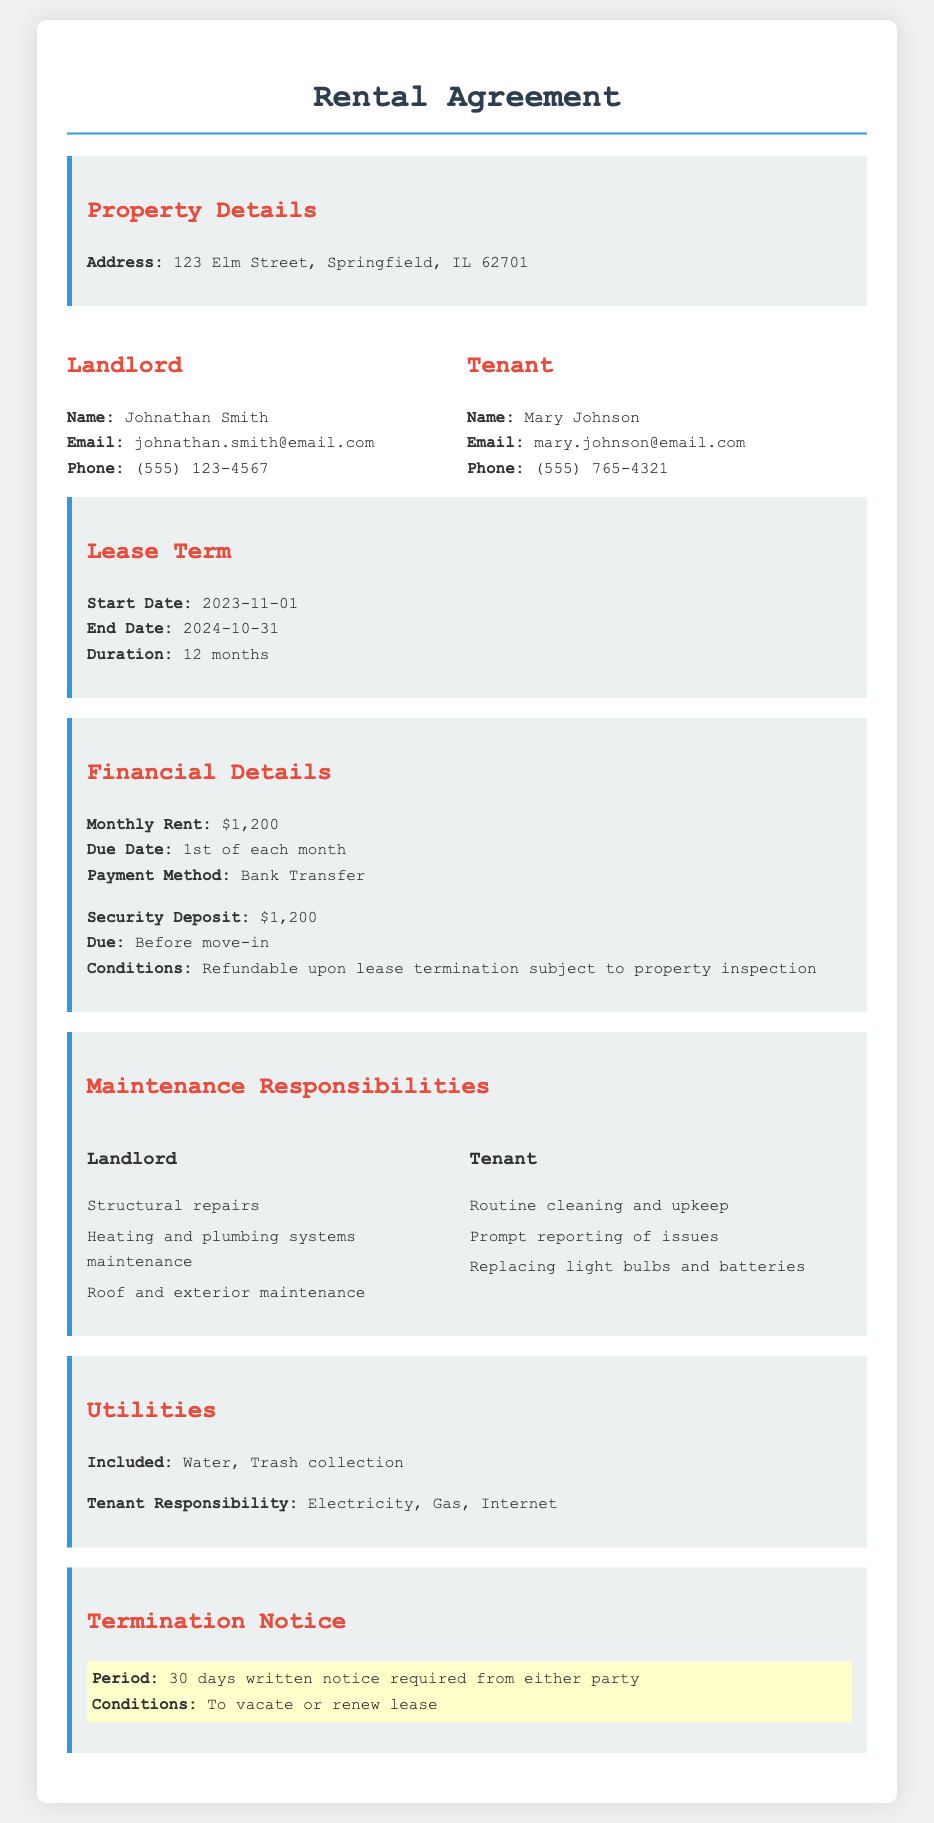what is the monthly rent? The monthly rent is stated clearly in the financial details section of the document.
Answer: $1,200 who is the landlord? The document specifies the name of the landlord at the beginning of the property details section.
Answer: Johnathan Smith what is the lease duration? The lease duration is included in the lease term section of the document, indicating the length of the agreement.
Answer: 12 months when does the lease start? The lease start date is provided in the lease term section, indicating when the tenant can move in.
Answer: 2023-11-01 who is responsible for structural repairs? The maintenance responsibilities section outlines duties for both landlord and tenant and specifies who handles structural repairs.
Answer: Landlord what utilities are included? The utilities section indicates which services are provided without additional charges to the tenant.
Answer: Water, Trash collection how many days notice is required to terminate the lease? The termination notice section specifies the notice period required for lease termination.
Answer: 30 days what payment method is specified? The financial details section outlines how the tenant should pay the monthly rent to the landlord.
Answer: Bank Transfer what is the security deposit amount? The financial details section mentions the amount that needs to be paid as a security deposit before moving in.
Answer: $1,200 